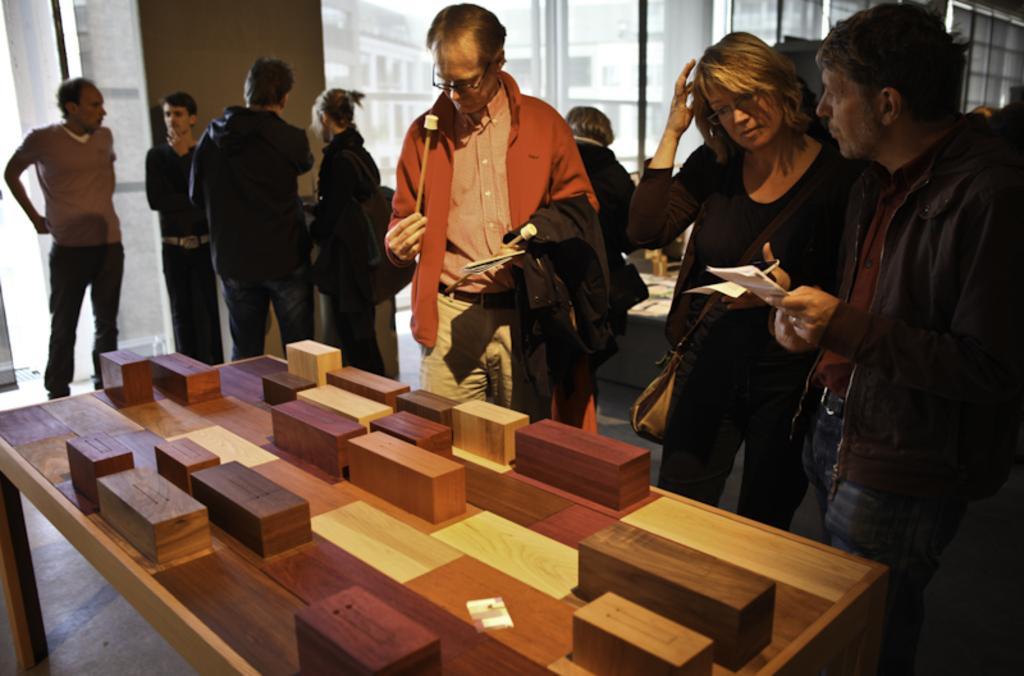How would you summarize this image in a sentence or two? In this image there are group of people. At the front there is a table with wooden blocks on the table. At the back there is a window and there is a building outside the window. The person with orange jacket is holding sticks. 